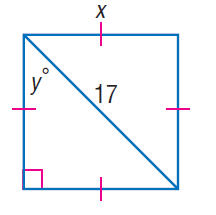Question: Find x.
Choices:
A. \frac { 17 \sqrt { 2 } } { 2 }
B. 17
C. 17 \sqrt { 2 }
D. 34
Answer with the letter. Answer: A 